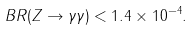<formula> <loc_0><loc_0><loc_500><loc_500>B R ( Z \rightarrow \gamma \gamma ) < 1 . 4 \times 1 0 ^ { - 4 } .</formula> 